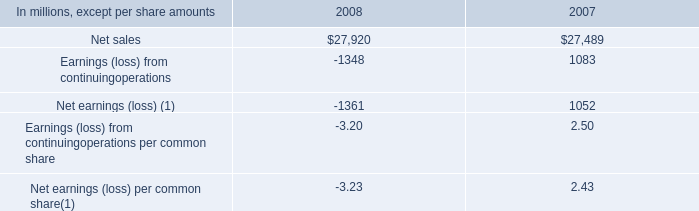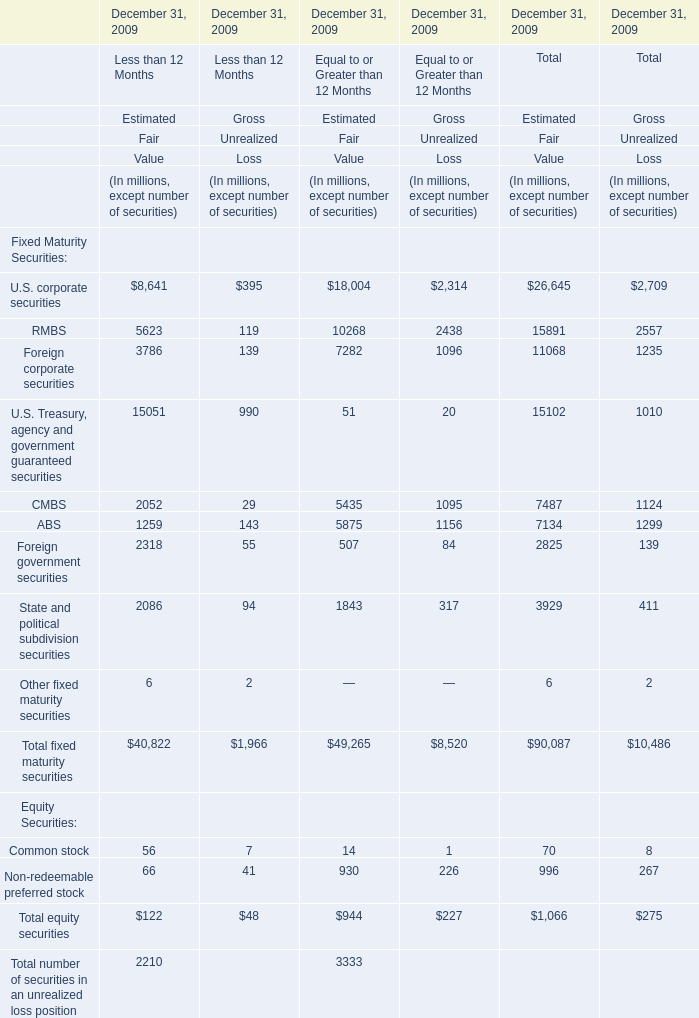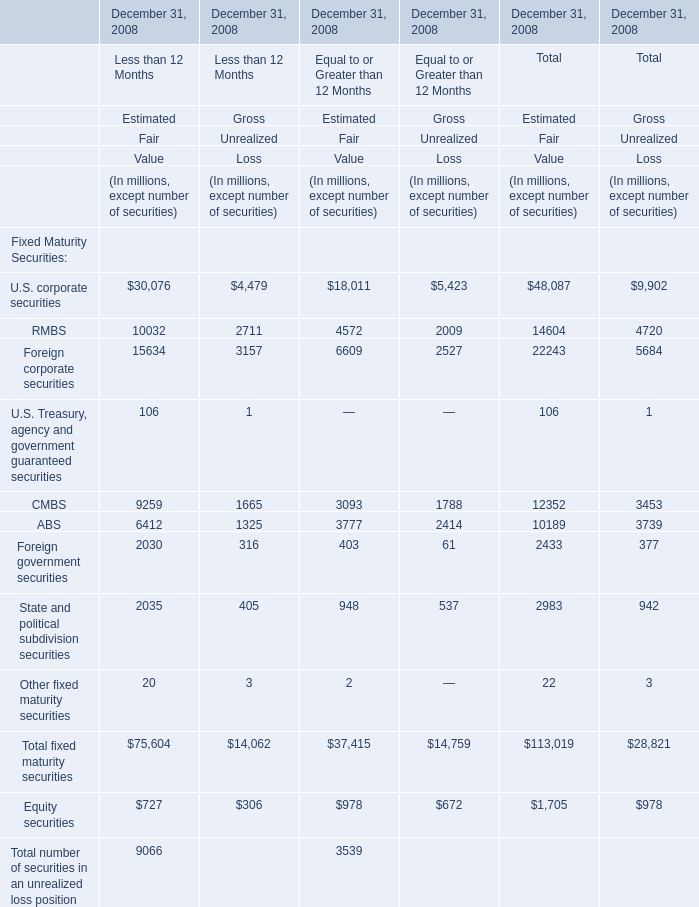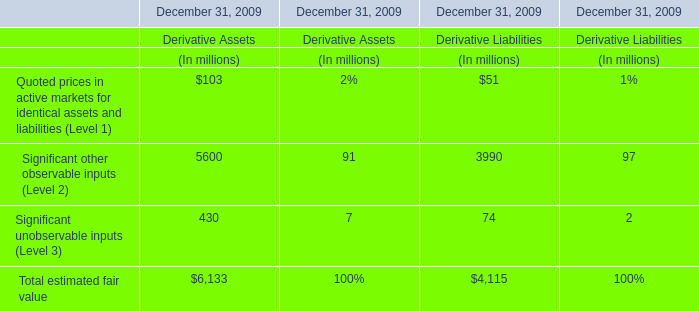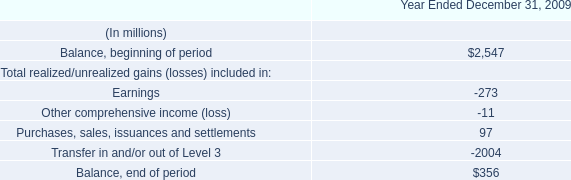In terms of Estimated Fair Value for Equal to or Greater than 12 Months,what is the ratio of ABS to Total fixed maturity securities? 
Computations: (3777 / 37415)
Answer: 0.10095. 